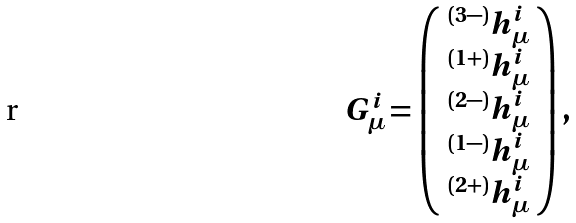<formula> <loc_0><loc_0><loc_500><loc_500>G ^ { i } _ { \mu } = \left ( \begin{array} { c } ^ { ( 3 - ) } h ^ { i } _ { \mu } \\ ^ { ( 1 + ) } h ^ { i } _ { \mu } \\ ^ { ( 2 - ) } h ^ { i } _ { \mu } \\ ^ { ( 1 - ) } h ^ { i } _ { \mu } \\ ^ { ( 2 + ) } h ^ { i } _ { \mu } \end{array} \right ) ,</formula> 